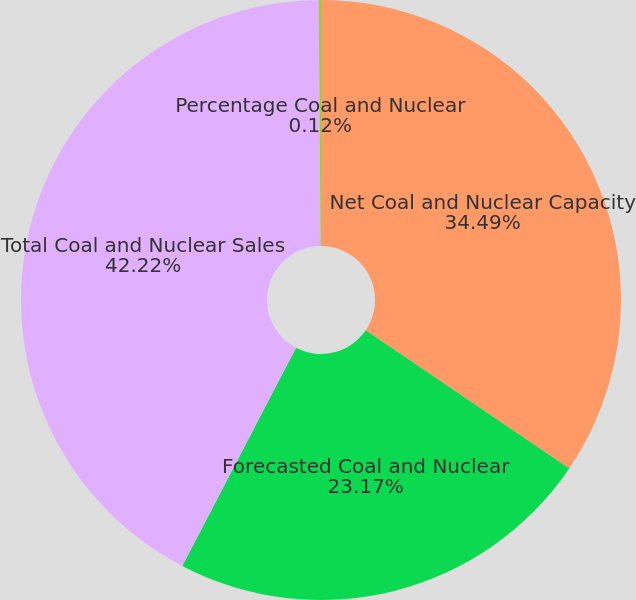Convert chart to OTSL. <chart><loc_0><loc_0><loc_500><loc_500><pie_chart><fcel>Net Coal and Nuclear Capacity<fcel>Forecasted Coal and Nuclear<fcel>Total Coal and Nuclear Sales<fcel>Percentage Coal and Nuclear<nl><fcel>34.49%<fcel>23.17%<fcel>42.23%<fcel>0.12%<nl></chart> 